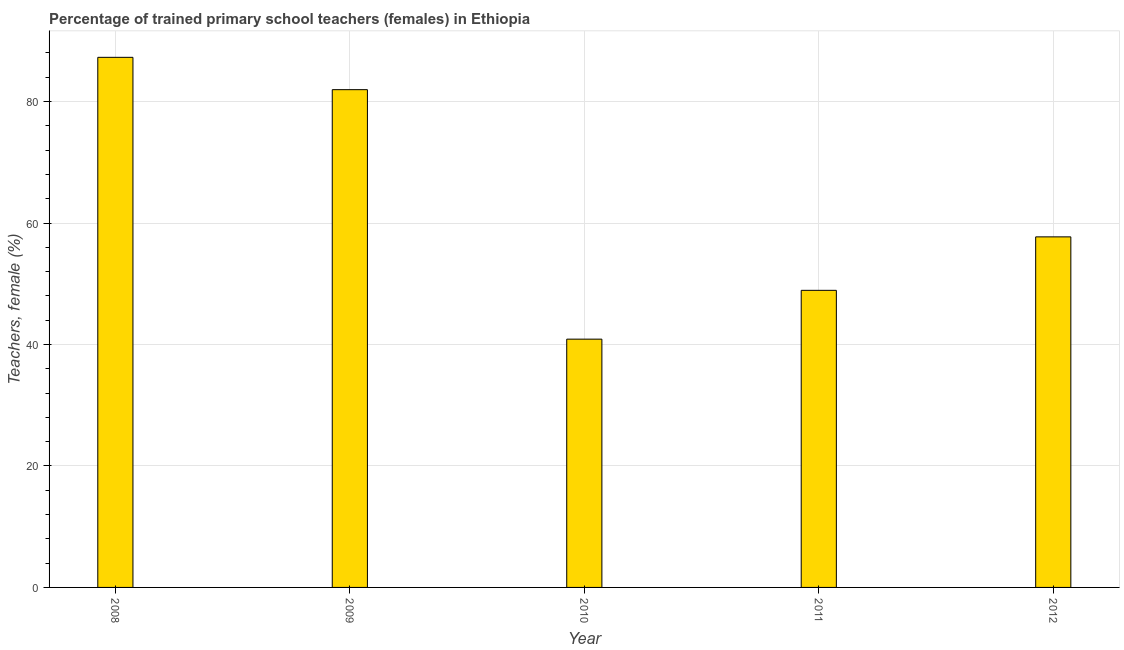Does the graph contain any zero values?
Your response must be concise. No. Does the graph contain grids?
Keep it short and to the point. Yes. What is the title of the graph?
Make the answer very short. Percentage of trained primary school teachers (females) in Ethiopia. What is the label or title of the X-axis?
Ensure brevity in your answer.  Year. What is the label or title of the Y-axis?
Ensure brevity in your answer.  Teachers, female (%). What is the percentage of trained female teachers in 2011?
Provide a succinct answer. 48.92. Across all years, what is the maximum percentage of trained female teachers?
Give a very brief answer. 87.28. Across all years, what is the minimum percentage of trained female teachers?
Your response must be concise. 40.88. In which year was the percentage of trained female teachers maximum?
Keep it short and to the point. 2008. What is the sum of the percentage of trained female teachers?
Provide a succinct answer. 316.77. What is the difference between the percentage of trained female teachers in 2010 and 2011?
Give a very brief answer. -8.04. What is the average percentage of trained female teachers per year?
Your response must be concise. 63.35. What is the median percentage of trained female teachers?
Make the answer very short. 57.72. Do a majority of the years between 2009 and 2011 (inclusive) have percentage of trained female teachers greater than 28 %?
Keep it short and to the point. Yes. What is the ratio of the percentage of trained female teachers in 2011 to that in 2012?
Your answer should be very brief. 0.85. Is the difference between the percentage of trained female teachers in 2010 and 2011 greater than the difference between any two years?
Give a very brief answer. No. What is the difference between the highest and the second highest percentage of trained female teachers?
Offer a terse response. 5.32. What is the difference between the highest and the lowest percentage of trained female teachers?
Your response must be concise. 46.4. Are all the bars in the graph horizontal?
Your answer should be compact. No. How many years are there in the graph?
Ensure brevity in your answer.  5. What is the difference between two consecutive major ticks on the Y-axis?
Your answer should be very brief. 20. Are the values on the major ticks of Y-axis written in scientific E-notation?
Offer a terse response. No. What is the Teachers, female (%) in 2008?
Your answer should be compact. 87.28. What is the Teachers, female (%) in 2009?
Your answer should be very brief. 81.96. What is the Teachers, female (%) in 2010?
Give a very brief answer. 40.88. What is the Teachers, female (%) of 2011?
Offer a very short reply. 48.92. What is the Teachers, female (%) of 2012?
Keep it short and to the point. 57.72. What is the difference between the Teachers, female (%) in 2008 and 2009?
Keep it short and to the point. 5.32. What is the difference between the Teachers, female (%) in 2008 and 2010?
Offer a very short reply. 46.4. What is the difference between the Teachers, female (%) in 2008 and 2011?
Your response must be concise. 38.37. What is the difference between the Teachers, female (%) in 2008 and 2012?
Your response must be concise. 29.56. What is the difference between the Teachers, female (%) in 2009 and 2010?
Your answer should be very brief. 41.08. What is the difference between the Teachers, female (%) in 2009 and 2011?
Offer a very short reply. 33.04. What is the difference between the Teachers, female (%) in 2009 and 2012?
Your response must be concise. 24.24. What is the difference between the Teachers, female (%) in 2010 and 2011?
Ensure brevity in your answer.  -8.04. What is the difference between the Teachers, female (%) in 2010 and 2012?
Give a very brief answer. -16.84. What is the difference between the Teachers, female (%) in 2011 and 2012?
Make the answer very short. -8.8. What is the ratio of the Teachers, female (%) in 2008 to that in 2009?
Your response must be concise. 1.06. What is the ratio of the Teachers, female (%) in 2008 to that in 2010?
Your answer should be very brief. 2.13. What is the ratio of the Teachers, female (%) in 2008 to that in 2011?
Ensure brevity in your answer.  1.78. What is the ratio of the Teachers, female (%) in 2008 to that in 2012?
Give a very brief answer. 1.51. What is the ratio of the Teachers, female (%) in 2009 to that in 2010?
Keep it short and to the point. 2. What is the ratio of the Teachers, female (%) in 2009 to that in 2011?
Make the answer very short. 1.68. What is the ratio of the Teachers, female (%) in 2009 to that in 2012?
Offer a very short reply. 1.42. What is the ratio of the Teachers, female (%) in 2010 to that in 2011?
Provide a short and direct response. 0.84. What is the ratio of the Teachers, female (%) in 2010 to that in 2012?
Offer a very short reply. 0.71. What is the ratio of the Teachers, female (%) in 2011 to that in 2012?
Offer a very short reply. 0.85. 